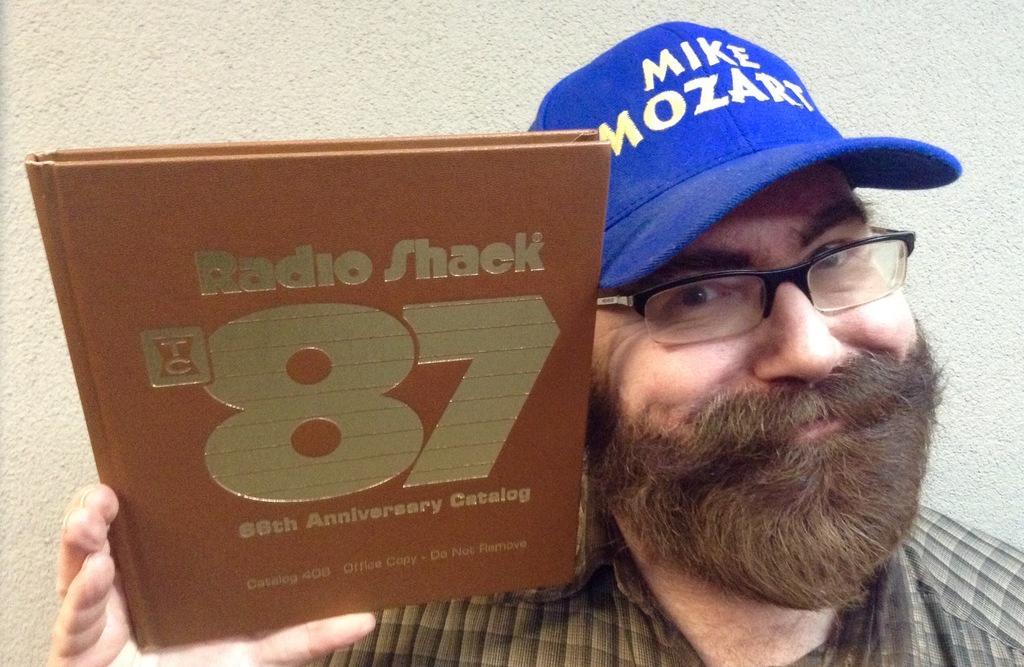How would you summarize this image in a sentence or two? We can see a man is holding a book in his hand and there is a cap on his head. In the background there is a wall. 